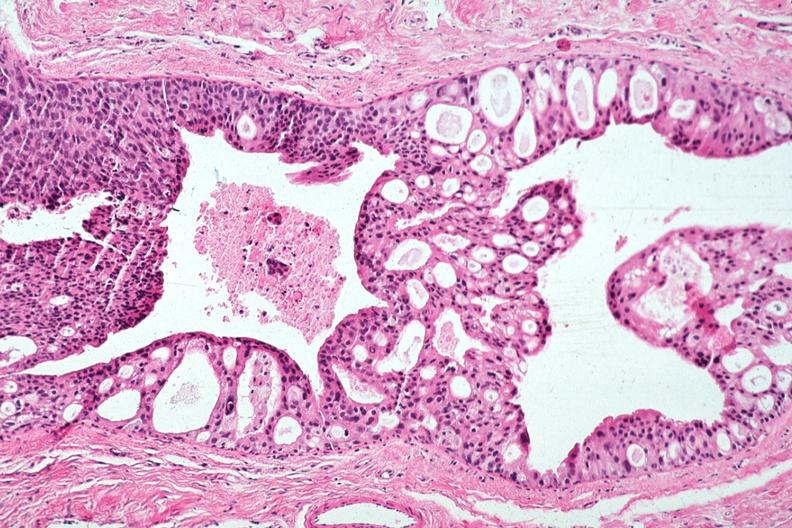what is present?
Answer the question using a single word or phrase. Papillary intraductal adenocarcinoma 